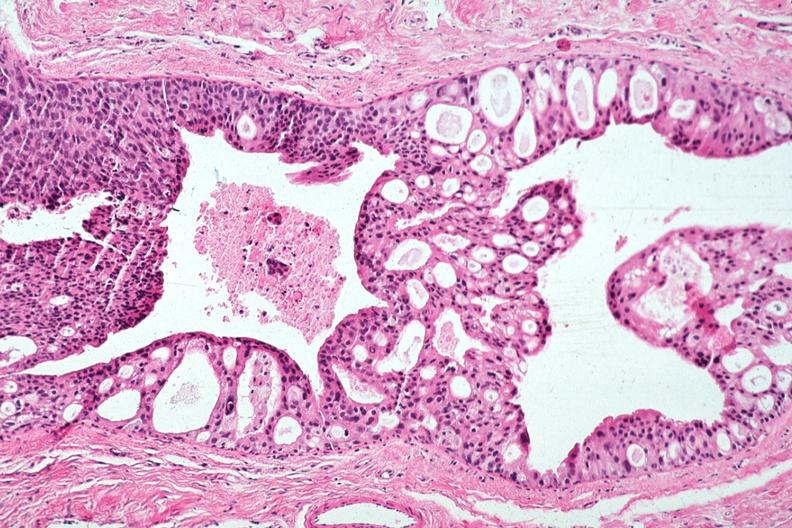what is present?
Answer the question using a single word or phrase. Papillary intraductal adenocarcinoma 